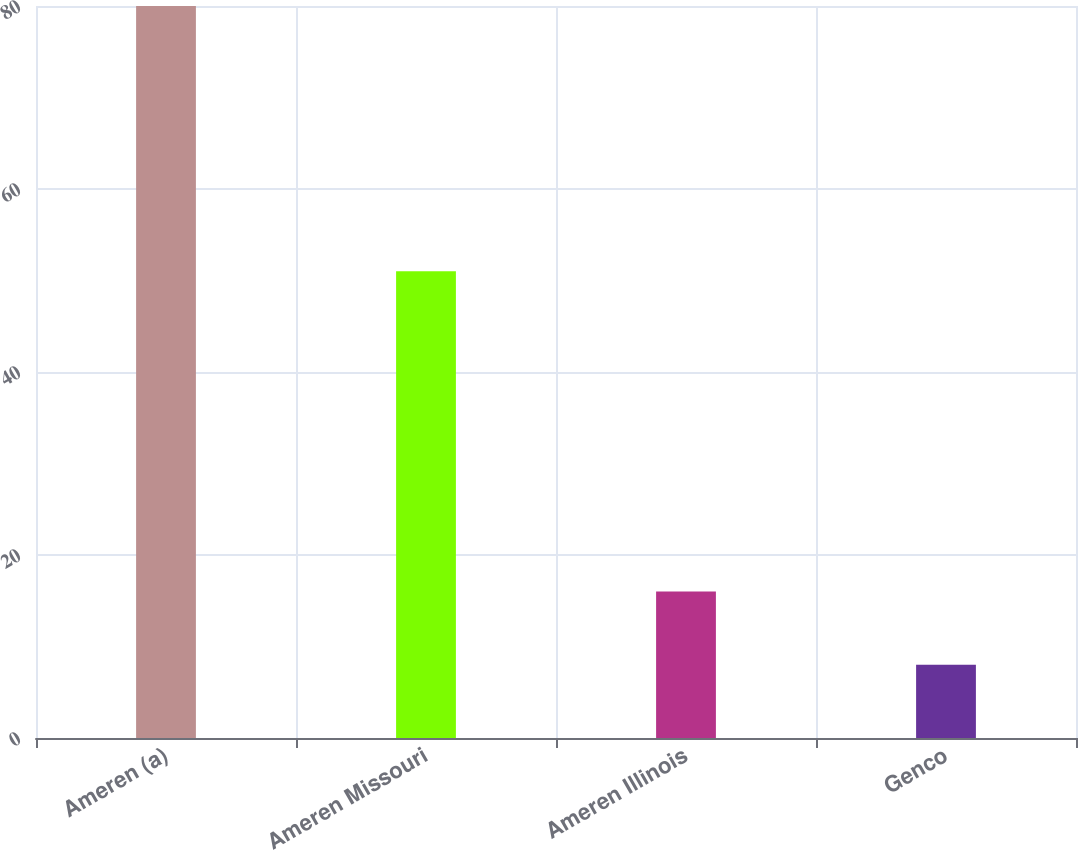<chart> <loc_0><loc_0><loc_500><loc_500><bar_chart><fcel>Ameren (a)<fcel>Ameren Missouri<fcel>Ameren Illinois<fcel>Genco<nl><fcel>80<fcel>51<fcel>16<fcel>8<nl></chart> 